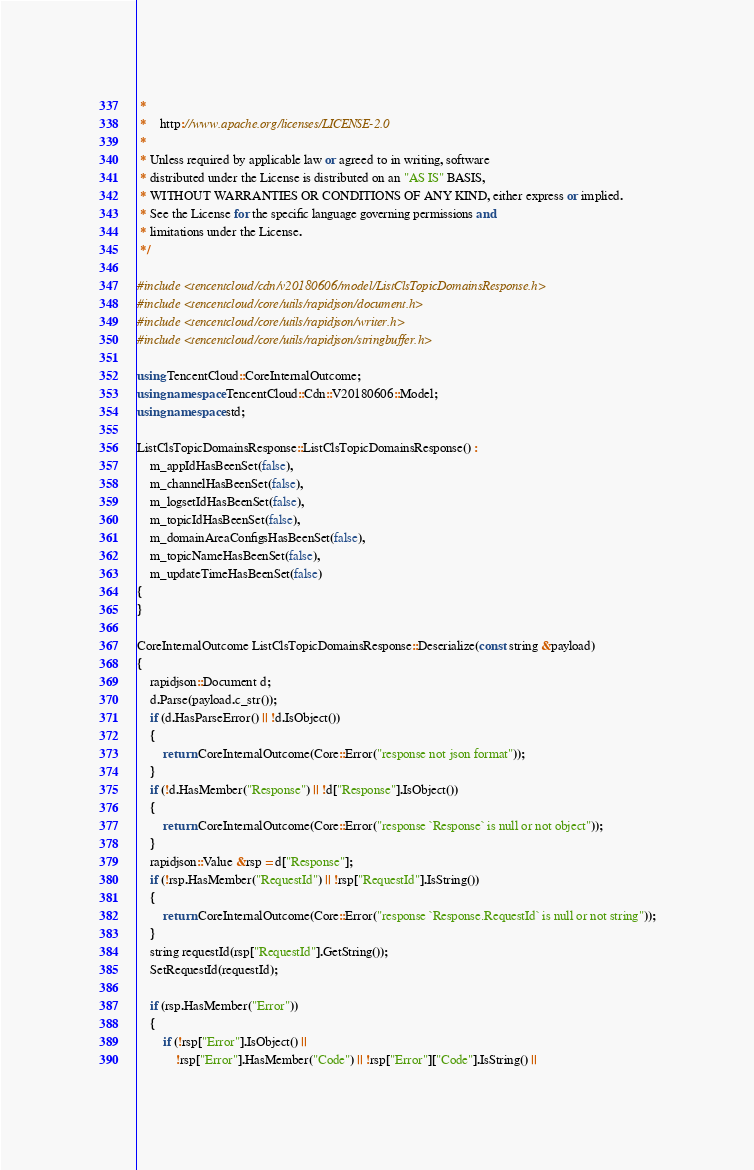<code> <loc_0><loc_0><loc_500><loc_500><_C++_> *
 *    http://www.apache.org/licenses/LICENSE-2.0
 *
 * Unless required by applicable law or agreed to in writing, software
 * distributed under the License is distributed on an "AS IS" BASIS,
 * WITHOUT WARRANTIES OR CONDITIONS OF ANY KIND, either express or implied.
 * See the License for the specific language governing permissions and
 * limitations under the License.
 */

#include <tencentcloud/cdn/v20180606/model/ListClsTopicDomainsResponse.h>
#include <tencentcloud/core/utils/rapidjson/document.h>
#include <tencentcloud/core/utils/rapidjson/writer.h>
#include <tencentcloud/core/utils/rapidjson/stringbuffer.h>

using TencentCloud::CoreInternalOutcome;
using namespace TencentCloud::Cdn::V20180606::Model;
using namespace std;

ListClsTopicDomainsResponse::ListClsTopicDomainsResponse() :
    m_appIdHasBeenSet(false),
    m_channelHasBeenSet(false),
    m_logsetIdHasBeenSet(false),
    m_topicIdHasBeenSet(false),
    m_domainAreaConfigsHasBeenSet(false),
    m_topicNameHasBeenSet(false),
    m_updateTimeHasBeenSet(false)
{
}

CoreInternalOutcome ListClsTopicDomainsResponse::Deserialize(const string &payload)
{
    rapidjson::Document d;
    d.Parse(payload.c_str());
    if (d.HasParseError() || !d.IsObject())
    {
        return CoreInternalOutcome(Core::Error("response not json format"));
    }
    if (!d.HasMember("Response") || !d["Response"].IsObject())
    {
        return CoreInternalOutcome(Core::Error("response `Response` is null or not object"));
    }
    rapidjson::Value &rsp = d["Response"];
    if (!rsp.HasMember("RequestId") || !rsp["RequestId"].IsString())
    {
        return CoreInternalOutcome(Core::Error("response `Response.RequestId` is null or not string"));
    }
    string requestId(rsp["RequestId"].GetString());
    SetRequestId(requestId);

    if (rsp.HasMember("Error"))
    {
        if (!rsp["Error"].IsObject() ||
            !rsp["Error"].HasMember("Code") || !rsp["Error"]["Code"].IsString() ||</code> 